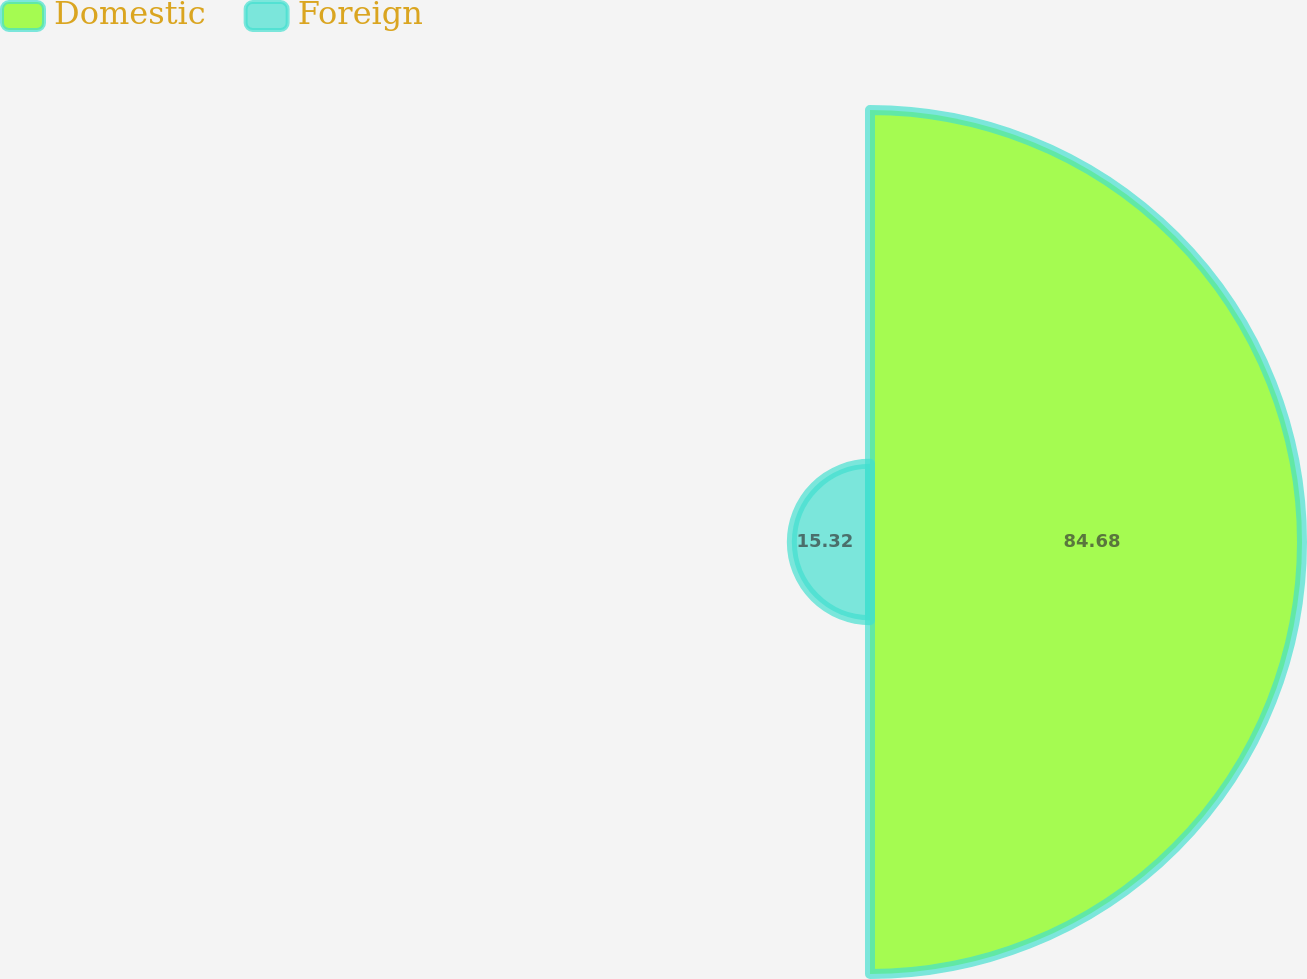<chart> <loc_0><loc_0><loc_500><loc_500><pie_chart><fcel>Domestic<fcel>Foreign<nl><fcel>84.68%<fcel>15.32%<nl></chart> 